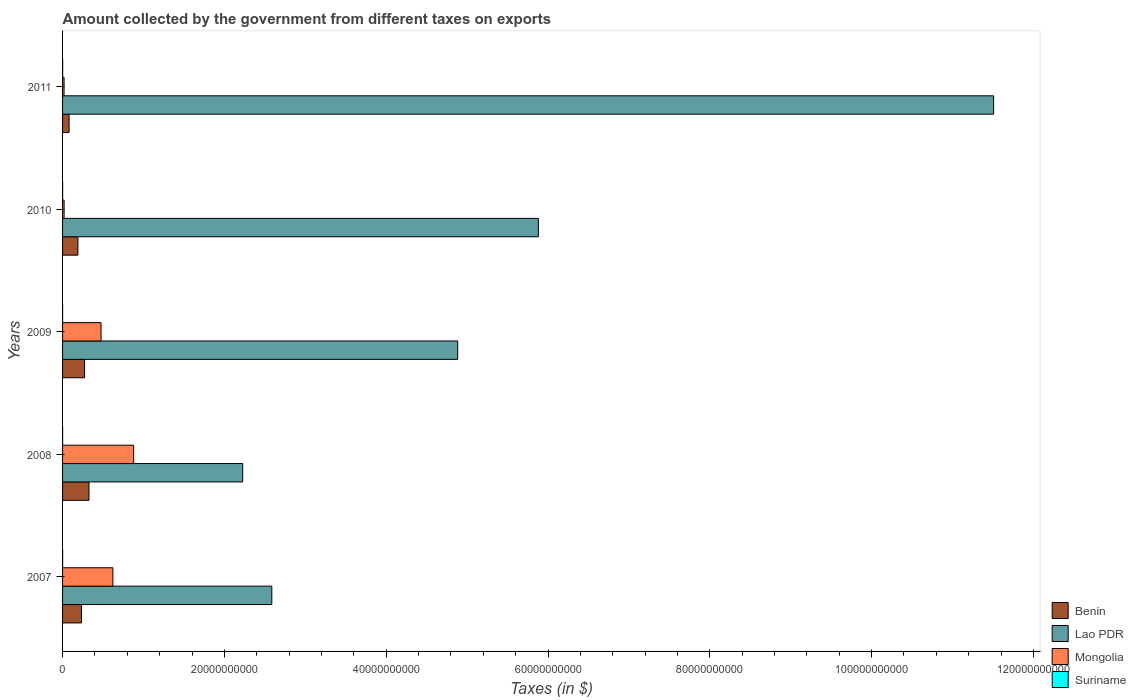How many groups of bars are there?
Keep it short and to the point. 5. Are the number of bars on each tick of the Y-axis equal?
Ensure brevity in your answer.  Yes. How many bars are there on the 1st tick from the top?
Ensure brevity in your answer.  4. How many bars are there on the 2nd tick from the bottom?
Offer a very short reply. 4. What is the label of the 4th group of bars from the top?
Ensure brevity in your answer.  2008. In how many cases, is the number of bars for a given year not equal to the number of legend labels?
Your answer should be very brief. 0. What is the amount collected by the government from taxes on exports in Benin in 2009?
Your response must be concise. 2.72e+09. Across all years, what is the maximum amount collected by the government from taxes on exports in Mongolia?
Ensure brevity in your answer.  8.78e+09. Across all years, what is the minimum amount collected by the government from taxes on exports in Mongolia?
Make the answer very short. 1.85e+08. What is the total amount collected by the government from taxes on exports in Mongolia in the graph?
Provide a succinct answer. 2.01e+1. What is the difference between the amount collected by the government from taxes on exports in Mongolia in 2010 and that in 2011?
Provide a short and direct response. 4.30e+06. What is the difference between the amount collected by the government from taxes on exports in Lao PDR in 2011 and the amount collected by the government from taxes on exports in Mongolia in 2008?
Keep it short and to the point. 1.06e+11. What is the average amount collected by the government from taxes on exports in Suriname per year?
Offer a very short reply. 6.93e+06. In the year 2009, what is the difference between the amount collected by the government from taxes on exports in Lao PDR and amount collected by the government from taxes on exports in Benin?
Your answer should be compact. 4.61e+1. What is the ratio of the amount collected by the government from taxes on exports in Lao PDR in 2007 to that in 2009?
Make the answer very short. 0.53. Is the amount collected by the government from taxes on exports in Suriname in 2008 less than that in 2010?
Keep it short and to the point. Yes. What is the difference between the highest and the second highest amount collected by the government from taxes on exports in Lao PDR?
Keep it short and to the point. 5.63e+1. What is the difference between the highest and the lowest amount collected by the government from taxes on exports in Lao PDR?
Provide a succinct answer. 9.28e+1. In how many years, is the amount collected by the government from taxes on exports in Suriname greater than the average amount collected by the government from taxes on exports in Suriname taken over all years?
Provide a succinct answer. 3. Is the sum of the amount collected by the government from taxes on exports in Mongolia in 2009 and 2010 greater than the maximum amount collected by the government from taxes on exports in Lao PDR across all years?
Provide a short and direct response. No. Is it the case that in every year, the sum of the amount collected by the government from taxes on exports in Mongolia and amount collected by the government from taxes on exports in Suriname is greater than the sum of amount collected by the government from taxes on exports in Lao PDR and amount collected by the government from taxes on exports in Benin?
Provide a succinct answer. No. What does the 2nd bar from the top in 2007 represents?
Give a very brief answer. Mongolia. What does the 4th bar from the bottom in 2010 represents?
Give a very brief answer. Suriname. How many bars are there?
Offer a very short reply. 20. How many years are there in the graph?
Ensure brevity in your answer.  5. What is the difference between two consecutive major ticks on the X-axis?
Keep it short and to the point. 2.00e+1. Are the values on the major ticks of X-axis written in scientific E-notation?
Offer a very short reply. No. Does the graph contain grids?
Offer a terse response. No. How are the legend labels stacked?
Your answer should be very brief. Vertical. What is the title of the graph?
Your answer should be compact. Amount collected by the government from different taxes on exports. Does "Turkey" appear as one of the legend labels in the graph?
Make the answer very short. No. What is the label or title of the X-axis?
Keep it short and to the point. Taxes (in $). What is the Taxes (in $) in Benin in 2007?
Give a very brief answer. 2.34e+09. What is the Taxes (in $) in Lao PDR in 2007?
Provide a short and direct response. 2.59e+1. What is the Taxes (in $) of Mongolia in 2007?
Your answer should be compact. 6.22e+09. What is the Taxes (in $) in Suriname in 2007?
Give a very brief answer. 7.95e+06. What is the Taxes (in $) in Benin in 2008?
Give a very brief answer. 3.27e+09. What is the Taxes (in $) of Lao PDR in 2008?
Your answer should be very brief. 2.23e+1. What is the Taxes (in $) in Mongolia in 2008?
Provide a short and direct response. 8.78e+09. What is the Taxes (in $) in Suriname in 2008?
Give a very brief answer. 5.36e+06. What is the Taxes (in $) of Benin in 2009?
Your answer should be very brief. 2.72e+09. What is the Taxes (in $) in Lao PDR in 2009?
Provide a short and direct response. 4.88e+1. What is the Taxes (in $) of Mongolia in 2009?
Ensure brevity in your answer.  4.75e+09. What is the Taxes (in $) in Suriname in 2009?
Your answer should be compact. 4.27e+06. What is the Taxes (in $) in Benin in 2010?
Offer a very short reply. 1.90e+09. What is the Taxes (in $) in Lao PDR in 2010?
Your answer should be compact. 5.88e+1. What is the Taxes (in $) of Mongolia in 2010?
Make the answer very short. 1.90e+08. What is the Taxes (in $) in Suriname in 2010?
Provide a succinct answer. 7.16e+06. What is the Taxes (in $) of Benin in 2011?
Give a very brief answer. 8.04e+08. What is the Taxes (in $) in Lao PDR in 2011?
Offer a terse response. 1.15e+11. What is the Taxes (in $) in Mongolia in 2011?
Your answer should be very brief. 1.85e+08. What is the Taxes (in $) in Suriname in 2011?
Your response must be concise. 9.93e+06. Across all years, what is the maximum Taxes (in $) of Benin?
Offer a terse response. 3.27e+09. Across all years, what is the maximum Taxes (in $) in Lao PDR?
Keep it short and to the point. 1.15e+11. Across all years, what is the maximum Taxes (in $) in Mongolia?
Make the answer very short. 8.78e+09. Across all years, what is the maximum Taxes (in $) in Suriname?
Ensure brevity in your answer.  9.93e+06. Across all years, what is the minimum Taxes (in $) of Benin?
Provide a short and direct response. 8.04e+08. Across all years, what is the minimum Taxes (in $) of Lao PDR?
Your answer should be compact. 2.23e+1. Across all years, what is the minimum Taxes (in $) in Mongolia?
Offer a very short reply. 1.85e+08. Across all years, what is the minimum Taxes (in $) of Suriname?
Provide a succinct answer. 4.27e+06. What is the total Taxes (in $) in Benin in the graph?
Offer a very short reply. 1.10e+1. What is the total Taxes (in $) in Lao PDR in the graph?
Your answer should be compact. 2.71e+11. What is the total Taxes (in $) of Mongolia in the graph?
Keep it short and to the point. 2.01e+1. What is the total Taxes (in $) in Suriname in the graph?
Your answer should be compact. 3.47e+07. What is the difference between the Taxes (in $) in Benin in 2007 and that in 2008?
Make the answer very short. -9.29e+08. What is the difference between the Taxes (in $) in Lao PDR in 2007 and that in 2008?
Your answer should be very brief. 3.60e+09. What is the difference between the Taxes (in $) in Mongolia in 2007 and that in 2008?
Offer a very short reply. -2.56e+09. What is the difference between the Taxes (in $) in Suriname in 2007 and that in 2008?
Give a very brief answer. 2.59e+06. What is the difference between the Taxes (in $) of Benin in 2007 and that in 2009?
Provide a short and direct response. -3.83e+08. What is the difference between the Taxes (in $) in Lao PDR in 2007 and that in 2009?
Provide a succinct answer. -2.30e+1. What is the difference between the Taxes (in $) in Mongolia in 2007 and that in 2009?
Offer a terse response. 1.46e+09. What is the difference between the Taxes (in $) of Suriname in 2007 and that in 2009?
Your response must be concise. 3.68e+06. What is the difference between the Taxes (in $) in Benin in 2007 and that in 2010?
Offer a terse response. 4.43e+08. What is the difference between the Taxes (in $) in Lao PDR in 2007 and that in 2010?
Your answer should be compact. -3.30e+1. What is the difference between the Taxes (in $) in Mongolia in 2007 and that in 2010?
Your response must be concise. 6.03e+09. What is the difference between the Taxes (in $) of Suriname in 2007 and that in 2010?
Make the answer very short. 7.86e+05. What is the difference between the Taxes (in $) of Benin in 2007 and that in 2011?
Offer a terse response. 1.53e+09. What is the difference between the Taxes (in $) of Lao PDR in 2007 and that in 2011?
Offer a very short reply. -8.92e+1. What is the difference between the Taxes (in $) of Mongolia in 2007 and that in 2011?
Your answer should be compact. 6.03e+09. What is the difference between the Taxes (in $) in Suriname in 2007 and that in 2011?
Provide a succinct answer. -1.98e+06. What is the difference between the Taxes (in $) of Benin in 2008 and that in 2009?
Offer a very short reply. 5.45e+08. What is the difference between the Taxes (in $) in Lao PDR in 2008 and that in 2009?
Ensure brevity in your answer.  -2.66e+1. What is the difference between the Taxes (in $) in Mongolia in 2008 and that in 2009?
Your answer should be compact. 4.03e+09. What is the difference between the Taxes (in $) in Suriname in 2008 and that in 2009?
Ensure brevity in your answer.  1.08e+06. What is the difference between the Taxes (in $) in Benin in 2008 and that in 2010?
Your answer should be very brief. 1.37e+09. What is the difference between the Taxes (in $) in Lao PDR in 2008 and that in 2010?
Keep it short and to the point. -3.65e+1. What is the difference between the Taxes (in $) in Mongolia in 2008 and that in 2010?
Offer a very short reply. 8.59e+09. What is the difference between the Taxes (in $) in Suriname in 2008 and that in 2010?
Make the answer very short. -1.81e+06. What is the difference between the Taxes (in $) in Benin in 2008 and that in 2011?
Keep it short and to the point. 2.46e+09. What is the difference between the Taxes (in $) of Lao PDR in 2008 and that in 2011?
Your answer should be compact. -9.28e+1. What is the difference between the Taxes (in $) in Mongolia in 2008 and that in 2011?
Your answer should be very brief. 8.60e+09. What is the difference between the Taxes (in $) of Suriname in 2008 and that in 2011?
Give a very brief answer. -4.58e+06. What is the difference between the Taxes (in $) of Benin in 2009 and that in 2010?
Offer a terse response. 8.26e+08. What is the difference between the Taxes (in $) in Lao PDR in 2009 and that in 2010?
Offer a very short reply. -9.98e+09. What is the difference between the Taxes (in $) in Mongolia in 2009 and that in 2010?
Provide a succinct answer. 4.57e+09. What is the difference between the Taxes (in $) of Suriname in 2009 and that in 2010?
Your answer should be compact. -2.89e+06. What is the difference between the Taxes (in $) in Benin in 2009 and that in 2011?
Your answer should be very brief. 1.92e+09. What is the difference between the Taxes (in $) of Lao PDR in 2009 and that in 2011?
Your response must be concise. -6.62e+1. What is the difference between the Taxes (in $) of Mongolia in 2009 and that in 2011?
Provide a short and direct response. 4.57e+09. What is the difference between the Taxes (in $) in Suriname in 2009 and that in 2011?
Ensure brevity in your answer.  -5.66e+06. What is the difference between the Taxes (in $) in Benin in 2010 and that in 2011?
Offer a terse response. 1.09e+09. What is the difference between the Taxes (in $) in Lao PDR in 2010 and that in 2011?
Your response must be concise. -5.63e+1. What is the difference between the Taxes (in $) in Mongolia in 2010 and that in 2011?
Your response must be concise. 4.30e+06. What is the difference between the Taxes (in $) of Suriname in 2010 and that in 2011?
Your answer should be compact. -2.77e+06. What is the difference between the Taxes (in $) in Benin in 2007 and the Taxes (in $) in Lao PDR in 2008?
Provide a short and direct response. -1.99e+1. What is the difference between the Taxes (in $) of Benin in 2007 and the Taxes (in $) of Mongolia in 2008?
Offer a terse response. -6.44e+09. What is the difference between the Taxes (in $) of Benin in 2007 and the Taxes (in $) of Suriname in 2008?
Provide a succinct answer. 2.33e+09. What is the difference between the Taxes (in $) in Lao PDR in 2007 and the Taxes (in $) in Mongolia in 2008?
Provide a succinct answer. 1.71e+1. What is the difference between the Taxes (in $) of Lao PDR in 2007 and the Taxes (in $) of Suriname in 2008?
Your answer should be compact. 2.59e+1. What is the difference between the Taxes (in $) in Mongolia in 2007 and the Taxes (in $) in Suriname in 2008?
Offer a terse response. 6.21e+09. What is the difference between the Taxes (in $) in Benin in 2007 and the Taxes (in $) in Lao PDR in 2009?
Give a very brief answer. -4.65e+1. What is the difference between the Taxes (in $) of Benin in 2007 and the Taxes (in $) of Mongolia in 2009?
Give a very brief answer. -2.42e+09. What is the difference between the Taxes (in $) of Benin in 2007 and the Taxes (in $) of Suriname in 2009?
Keep it short and to the point. 2.33e+09. What is the difference between the Taxes (in $) in Lao PDR in 2007 and the Taxes (in $) in Mongolia in 2009?
Keep it short and to the point. 2.11e+1. What is the difference between the Taxes (in $) of Lao PDR in 2007 and the Taxes (in $) of Suriname in 2009?
Give a very brief answer. 2.59e+1. What is the difference between the Taxes (in $) in Mongolia in 2007 and the Taxes (in $) in Suriname in 2009?
Your response must be concise. 6.21e+09. What is the difference between the Taxes (in $) in Benin in 2007 and the Taxes (in $) in Lao PDR in 2010?
Keep it short and to the point. -5.65e+1. What is the difference between the Taxes (in $) in Benin in 2007 and the Taxes (in $) in Mongolia in 2010?
Give a very brief answer. 2.15e+09. What is the difference between the Taxes (in $) of Benin in 2007 and the Taxes (in $) of Suriname in 2010?
Your response must be concise. 2.33e+09. What is the difference between the Taxes (in $) of Lao PDR in 2007 and the Taxes (in $) of Mongolia in 2010?
Offer a very short reply. 2.57e+1. What is the difference between the Taxes (in $) of Lao PDR in 2007 and the Taxes (in $) of Suriname in 2010?
Your answer should be very brief. 2.59e+1. What is the difference between the Taxes (in $) in Mongolia in 2007 and the Taxes (in $) in Suriname in 2010?
Provide a succinct answer. 6.21e+09. What is the difference between the Taxes (in $) of Benin in 2007 and the Taxes (in $) of Lao PDR in 2011?
Provide a short and direct response. -1.13e+11. What is the difference between the Taxes (in $) in Benin in 2007 and the Taxes (in $) in Mongolia in 2011?
Your answer should be compact. 2.15e+09. What is the difference between the Taxes (in $) of Benin in 2007 and the Taxes (in $) of Suriname in 2011?
Give a very brief answer. 2.33e+09. What is the difference between the Taxes (in $) in Lao PDR in 2007 and the Taxes (in $) in Mongolia in 2011?
Offer a very short reply. 2.57e+1. What is the difference between the Taxes (in $) in Lao PDR in 2007 and the Taxes (in $) in Suriname in 2011?
Your response must be concise. 2.59e+1. What is the difference between the Taxes (in $) in Mongolia in 2007 and the Taxes (in $) in Suriname in 2011?
Offer a terse response. 6.21e+09. What is the difference between the Taxes (in $) of Benin in 2008 and the Taxes (in $) of Lao PDR in 2009?
Keep it short and to the point. -4.56e+1. What is the difference between the Taxes (in $) in Benin in 2008 and the Taxes (in $) in Mongolia in 2009?
Your response must be concise. -1.49e+09. What is the difference between the Taxes (in $) of Benin in 2008 and the Taxes (in $) of Suriname in 2009?
Provide a succinct answer. 3.26e+09. What is the difference between the Taxes (in $) of Lao PDR in 2008 and the Taxes (in $) of Mongolia in 2009?
Your response must be concise. 1.75e+1. What is the difference between the Taxes (in $) in Lao PDR in 2008 and the Taxes (in $) in Suriname in 2009?
Your response must be concise. 2.23e+1. What is the difference between the Taxes (in $) in Mongolia in 2008 and the Taxes (in $) in Suriname in 2009?
Ensure brevity in your answer.  8.78e+09. What is the difference between the Taxes (in $) of Benin in 2008 and the Taxes (in $) of Lao PDR in 2010?
Your answer should be very brief. -5.55e+1. What is the difference between the Taxes (in $) in Benin in 2008 and the Taxes (in $) in Mongolia in 2010?
Your response must be concise. 3.08e+09. What is the difference between the Taxes (in $) in Benin in 2008 and the Taxes (in $) in Suriname in 2010?
Your answer should be compact. 3.26e+09. What is the difference between the Taxes (in $) of Lao PDR in 2008 and the Taxes (in $) of Mongolia in 2010?
Provide a short and direct response. 2.21e+1. What is the difference between the Taxes (in $) of Lao PDR in 2008 and the Taxes (in $) of Suriname in 2010?
Keep it short and to the point. 2.23e+1. What is the difference between the Taxes (in $) of Mongolia in 2008 and the Taxes (in $) of Suriname in 2010?
Ensure brevity in your answer.  8.78e+09. What is the difference between the Taxes (in $) in Benin in 2008 and the Taxes (in $) in Lao PDR in 2011?
Your response must be concise. -1.12e+11. What is the difference between the Taxes (in $) of Benin in 2008 and the Taxes (in $) of Mongolia in 2011?
Your answer should be compact. 3.08e+09. What is the difference between the Taxes (in $) in Benin in 2008 and the Taxes (in $) in Suriname in 2011?
Offer a very short reply. 3.26e+09. What is the difference between the Taxes (in $) in Lao PDR in 2008 and the Taxes (in $) in Mongolia in 2011?
Ensure brevity in your answer.  2.21e+1. What is the difference between the Taxes (in $) of Lao PDR in 2008 and the Taxes (in $) of Suriname in 2011?
Your answer should be compact. 2.23e+1. What is the difference between the Taxes (in $) of Mongolia in 2008 and the Taxes (in $) of Suriname in 2011?
Ensure brevity in your answer.  8.77e+09. What is the difference between the Taxes (in $) in Benin in 2009 and the Taxes (in $) in Lao PDR in 2010?
Keep it short and to the point. -5.61e+1. What is the difference between the Taxes (in $) of Benin in 2009 and the Taxes (in $) of Mongolia in 2010?
Give a very brief answer. 2.53e+09. What is the difference between the Taxes (in $) of Benin in 2009 and the Taxes (in $) of Suriname in 2010?
Offer a very short reply. 2.71e+09. What is the difference between the Taxes (in $) of Lao PDR in 2009 and the Taxes (in $) of Mongolia in 2010?
Provide a short and direct response. 4.86e+1. What is the difference between the Taxes (in $) in Lao PDR in 2009 and the Taxes (in $) in Suriname in 2010?
Make the answer very short. 4.88e+1. What is the difference between the Taxes (in $) in Mongolia in 2009 and the Taxes (in $) in Suriname in 2010?
Offer a very short reply. 4.75e+09. What is the difference between the Taxes (in $) in Benin in 2009 and the Taxes (in $) in Lao PDR in 2011?
Make the answer very short. -1.12e+11. What is the difference between the Taxes (in $) of Benin in 2009 and the Taxes (in $) of Mongolia in 2011?
Provide a short and direct response. 2.54e+09. What is the difference between the Taxes (in $) in Benin in 2009 and the Taxes (in $) in Suriname in 2011?
Your answer should be very brief. 2.71e+09. What is the difference between the Taxes (in $) in Lao PDR in 2009 and the Taxes (in $) in Mongolia in 2011?
Give a very brief answer. 4.87e+1. What is the difference between the Taxes (in $) in Lao PDR in 2009 and the Taxes (in $) in Suriname in 2011?
Give a very brief answer. 4.88e+1. What is the difference between the Taxes (in $) of Mongolia in 2009 and the Taxes (in $) of Suriname in 2011?
Your answer should be very brief. 4.74e+09. What is the difference between the Taxes (in $) in Benin in 2010 and the Taxes (in $) in Lao PDR in 2011?
Make the answer very short. -1.13e+11. What is the difference between the Taxes (in $) of Benin in 2010 and the Taxes (in $) of Mongolia in 2011?
Give a very brief answer. 1.71e+09. What is the difference between the Taxes (in $) in Benin in 2010 and the Taxes (in $) in Suriname in 2011?
Ensure brevity in your answer.  1.89e+09. What is the difference between the Taxes (in $) in Lao PDR in 2010 and the Taxes (in $) in Mongolia in 2011?
Make the answer very short. 5.86e+1. What is the difference between the Taxes (in $) of Lao PDR in 2010 and the Taxes (in $) of Suriname in 2011?
Keep it short and to the point. 5.88e+1. What is the difference between the Taxes (in $) in Mongolia in 2010 and the Taxes (in $) in Suriname in 2011?
Keep it short and to the point. 1.80e+08. What is the average Taxes (in $) of Benin per year?
Your answer should be compact. 2.21e+09. What is the average Taxes (in $) in Lao PDR per year?
Keep it short and to the point. 5.42e+1. What is the average Taxes (in $) in Mongolia per year?
Provide a short and direct response. 4.03e+09. What is the average Taxes (in $) of Suriname per year?
Keep it short and to the point. 6.93e+06. In the year 2007, what is the difference between the Taxes (in $) of Benin and Taxes (in $) of Lao PDR?
Ensure brevity in your answer.  -2.35e+1. In the year 2007, what is the difference between the Taxes (in $) in Benin and Taxes (in $) in Mongolia?
Give a very brief answer. -3.88e+09. In the year 2007, what is the difference between the Taxes (in $) of Benin and Taxes (in $) of Suriname?
Give a very brief answer. 2.33e+09. In the year 2007, what is the difference between the Taxes (in $) of Lao PDR and Taxes (in $) of Mongolia?
Provide a short and direct response. 1.96e+1. In the year 2007, what is the difference between the Taxes (in $) of Lao PDR and Taxes (in $) of Suriname?
Your answer should be very brief. 2.59e+1. In the year 2007, what is the difference between the Taxes (in $) in Mongolia and Taxes (in $) in Suriname?
Your answer should be compact. 6.21e+09. In the year 2008, what is the difference between the Taxes (in $) of Benin and Taxes (in $) of Lao PDR?
Offer a very short reply. -1.90e+1. In the year 2008, what is the difference between the Taxes (in $) of Benin and Taxes (in $) of Mongolia?
Offer a terse response. -5.52e+09. In the year 2008, what is the difference between the Taxes (in $) in Benin and Taxes (in $) in Suriname?
Give a very brief answer. 3.26e+09. In the year 2008, what is the difference between the Taxes (in $) of Lao PDR and Taxes (in $) of Mongolia?
Your answer should be compact. 1.35e+1. In the year 2008, what is the difference between the Taxes (in $) in Lao PDR and Taxes (in $) in Suriname?
Your response must be concise. 2.23e+1. In the year 2008, what is the difference between the Taxes (in $) in Mongolia and Taxes (in $) in Suriname?
Your answer should be very brief. 8.78e+09. In the year 2009, what is the difference between the Taxes (in $) in Benin and Taxes (in $) in Lao PDR?
Offer a very short reply. -4.61e+1. In the year 2009, what is the difference between the Taxes (in $) in Benin and Taxes (in $) in Mongolia?
Your answer should be compact. -2.03e+09. In the year 2009, what is the difference between the Taxes (in $) of Benin and Taxes (in $) of Suriname?
Provide a succinct answer. 2.72e+09. In the year 2009, what is the difference between the Taxes (in $) in Lao PDR and Taxes (in $) in Mongolia?
Provide a short and direct response. 4.41e+1. In the year 2009, what is the difference between the Taxes (in $) of Lao PDR and Taxes (in $) of Suriname?
Offer a terse response. 4.88e+1. In the year 2009, what is the difference between the Taxes (in $) in Mongolia and Taxes (in $) in Suriname?
Offer a very short reply. 4.75e+09. In the year 2010, what is the difference between the Taxes (in $) of Benin and Taxes (in $) of Lao PDR?
Ensure brevity in your answer.  -5.69e+1. In the year 2010, what is the difference between the Taxes (in $) in Benin and Taxes (in $) in Mongolia?
Keep it short and to the point. 1.71e+09. In the year 2010, what is the difference between the Taxes (in $) in Benin and Taxes (in $) in Suriname?
Make the answer very short. 1.89e+09. In the year 2010, what is the difference between the Taxes (in $) in Lao PDR and Taxes (in $) in Mongolia?
Offer a very short reply. 5.86e+1. In the year 2010, what is the difference between the Taxes (in $) in Lao PDR and Taxes (in $) in Suriname?
Your answer should be compact. 5.88e+1. In the year 2010, what is the difference between the Taxes (in $) in Mongolia and Taxes (in $) in Suriname?
Ensure brevity in your answer.  1.83e+08. In the year 2011, what is the difference between the Taxes (in $) of Benin and Taxes (in $) of Lao PDR?
Give a very brief answer. -1.14e+11. In the year 2011, what is the difference between the Taxes (in $) in Benin and Taxes (in $) in Mongolia?
Your answer should be compact. 6.18e+08. In the year 2011, what is the difference between the Taxes (in $) of Benin and Taxes (in $) of Suriname?
Offer a very short reply. 7.94e+08. In the year 2011, what is the difference between the Taxes (in $) of Lao PDR and Taxes (in $) of Mongolia?
Give a very brief answer. 1.15e+11. In the year 2011, what is the difference between the Taxes (in $) in Lao PDR and Taxes (in $) in Suriname?
Keep it short and to the point. 1.15e+11. In the year 2011, what is the difference between the Taxes (in $) of Mongolia and Taxes (in $) of Suriname?
Ensure brevity in your answer.  1.76e+08. What is the ratio of the Taxes (in $) in Benin in 2007 to that in 2008?
Ensure brevity in your answer.  0.72. What is the ratio of the Taxes (in $) of Lao PDR in 2007 to that in 2008?
Keep it short and to the point. 1.16. What is the ratio of the Taxes (in $) of Mongolia in 2007 to that in 2008?
Offer a terse response. 0.71. What is the ratio of the Taxes (in $) in Suriname in 2007 to that in 2008?
Your answer should be compact. 1.48. What is the ratio of the Taxes (in $) in Benin in 2007 to that in 2009?
Your response must be concise. 0.86. What is the ratio of the Taxes (in $) of Lao PDR in 2007 to that in 2009?
Give a very brief answer. 0.53. What is the ratio of the Taxes (in $) of Mongolia in 2007 to that in 2009?
Your answer should be compact. 1.31. What is the ratio of the Taxes (in $) in Suriname in 2007 to that in 2009?
Keep it short and to the point. 1.86. What is the ratio of the Taxes (in $) of Benin in 2007 to that in 2010?
Your response must be concise. 1.23. What is the ratio of the Taxes (in $) of Lao PDR in 2007 to that in 2010?
Give a very brief answer. 0.44. What is the ratio of the Taxes (in $) of Mongolia in 2007 to that in 2010?
Provide a succinct answer. 32.76. What is the ratio of the Taxes (in $) in Suriname in 2007 to that in 2010?
Your response must be concise. 1.11. What is the ratio of the Taxes (in $) in Benin in 2007 to that in 2011?
Offer a very short reply. 2.91. What is the ratio of the Taxes (in $) of Lao PDR in 2007 to that in 2011?
Offer a terse response. 0.22. What is the ratio of the Taxes (in $) of Mongolia in 2007 to that in 2011?
Make the answer very short. 33.52. What is the ratio of the Taxes (in $) in Suriname in 2007 to that in 2011?
Ensure brevity in your answer.  0.8. What is the ratio of the Taxes (in $) in Benin in 2008 to that in 2009?
Offer a very short reply. 1.2. What is the ratio of the Taxes (in $) in Lao PDR in 2008 to that in 2009?
Your answer should be very brief. 0.46. What is the ratio of the Taxes (in $) in Mongolia in 2008 to that in 2009?
Your answer should be compact. 1.85. What is the ratio of the Taxes (in $) of Suriname in 2008 to that in 2009?
Make the answer very short. 1.25. What is the ratio of the Taxes (in $) of Benin in 2008 to that in 2010?
Provide a succinct answer. 1.72. What is the ratio of the Taxes (in $) of Lao PDR in 2008 to that in 2010?
Your answer should be very brief. 0.38. What is the ratio of the Taxes (in $) in Mongolia in 2008 to that in 2010?
Offer a terse response. 46.27. What is the ratio of the Taxes (in $) of Suriname in 2008 to that in 2010?
Provide a succinct answer. 0.75. What is the ratio of the Taxes (in $) in Benin in 2008 to that in 2011?
Make the answer very short. 4.06. What is the ratio of the Taxes (in $) in Lao PDR in 2008 to that in 2011?
Provide a short and direct response. 0.19. What is the ratio of the Taxes (in $) of Mongolia in 2008 to that in 2011?
Your answer should be compact. 47.35. What is the ratio of the Taxes (in $) of Suriname in 2008 to that in 2011?
Make the answer very short. 0.54. What is the ratio of the Taxes (in $) of Benin in 2009 to that in 2010?
Provide a succinct answer. 1.44. What is the ratio of the Taxes (in $) of Lao PDR in 2009 to that in 2010?
Provide a short and direct response. 0.83. What is the ratio of the Taxes (in $) in Mongolia in 2009 to that in 2010?
Offer a terse response. 25.05. What is the ratio of the Taxes (in $) of Suriname in 2009 to that in 2010?
Keep it short and to the point. 0.6. What is the ratio of the Taxes (in $) of Benin in 2009 to that in 2011?
Your response must be concise. 3.39. What is the ratio of the Taxes (in $) in Lao PDR in 2009 to that in 2011?
Offer a very short reply. 0.42. What is the ratio of the Taxes (in $) in Mongolia in 2009 to that in 2011?
Your answer should be compact. 25.63. What is the ratio of the Taxes (in $) in Suriname in 2009 to that in 2011?
Give a very brief answer. 0.43. What is the ratio of the Taxes (in $) of Benin in 2010 to that in 2011?
Your response must be concise. 2.36. What is the ratio of the Taxes (in $) of Lao PDR in 2010 to that in 2011?
Provide a short and direct response. 0.51. What is the ratio of the Taxes (in $) of Mongolia in 2010 to that in 2011?
Your response must be concise. 1.02. What is the ratio of the Taxes (in $) of Suriname in 2010 to that in 2011?
Give a very brief answer. 0.72. What is the difference between the highest and the second highest Taxes (in $) of Benin?
Give a very brief answer. 5.45e+08. What is the difference between the highest and the second highest Taxes (in $) in Lao PDR?
Keep it short and to the point. 5.63e+1. What is the difference between the highest and the second highest Taxes (in $) of Mongolia?
Provide a short and direct response. 2.56e+09. What is the difference between the highest and the second highest Taxes (in $) in Suriname?
Make the answer very short. 1.98e+06. What is the difference between the highest and the lowest Taxes (in $) in Benin?
Provide a succinct answer. 2.46e+09. What is the difference between the highest and the lowest Taxes (in $) of Lao PDR?
Your answer should be very brief. 9.28e+1. What is the difference between the highest and the lowest Taxes (in $) in Mongolia?
Keep it short and to the point. 8.60e+09. What is the difference between the highest and the lowest Taxes (in $) of Suriname?
Your response must be concise. 5.66e+06. 